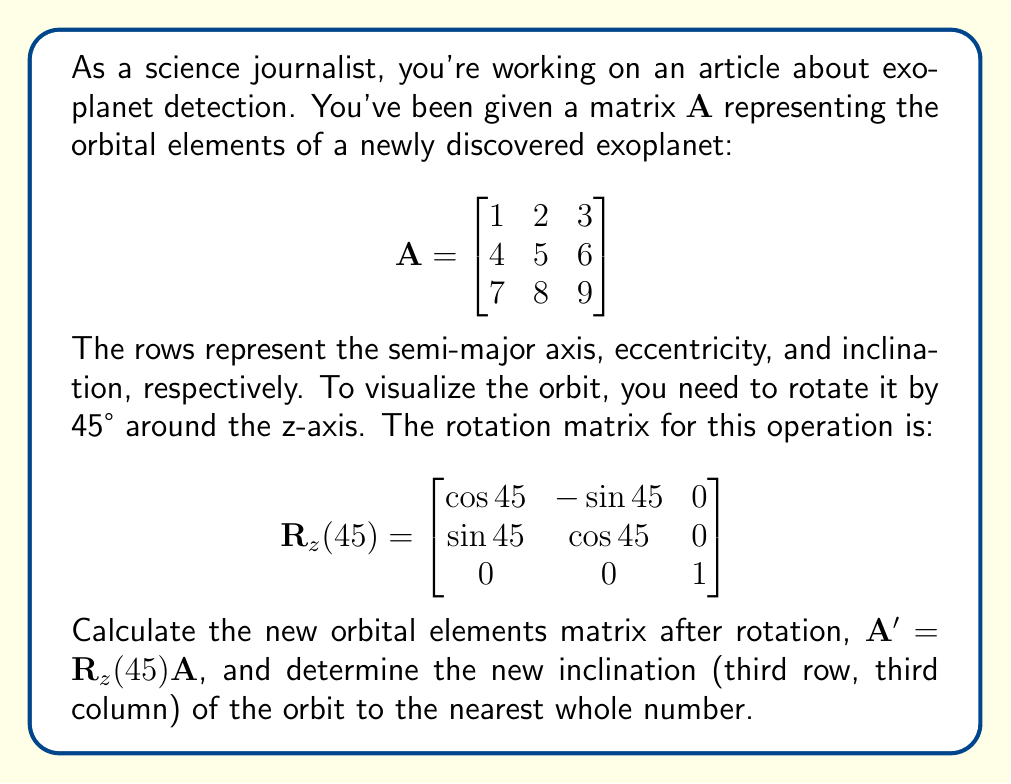Can you answer this question? Let's approach this step-by-step:

1) First, we need to calculate $\cos 45°$ and $\sin 45°$:
   $\cos 45° = \sin 45° = \frac{1}{\sqrt{2}} \approx 0.7071$

2) Now we can fill in the rotation matrix:

   $$\mathbf{R}_z(45°) = \begin{bmatrix}
   0.7071 & -0.7071 & 0 \\
   0.7071 & 0.7071 & 0 \\
   0 & 0 & 1
   \end{bmatrix}$$

3) To find $\mathbf{A}'$, we multiply $\mathbf{R}_z(45°)$ by $\mathbf{A}$:

   $$\mathbf{A}' = \mathbf{R}_z(45°) \mathbf{A} = \begin{bmatrix}
   0.7071 & -0.7071 & 0 \\
   0.7071 & 0.7071 & 0 \\
   0 & 0 & 1
   \end{bmatrix} \begin{bmatrix}
   1 & 2 & 3 \\
   4 & 5 & 6 \\
   7 & 8 & 9
   \end{bmatrix}$$

4) Performing the matrix multiplication:

   $$\mathbf{A}' = \begin{bmatrix}
   (0.7071 \times 1 + -0.7071 \times 4 + 0 \times 7) & (0.7071 \times 2 + -0.7071 \times 5 + 0 \times 8) & (0.7071 \times 3 + -0.7071 \times 6 + 0 \times 9) \\
   (0.7071 \times 1 + 0.7071 \times 4 + 0 \times 7) & (0.7071 \times 2 + 0.7071 \times 5 + 0 \times 8) & (0.7071 \times 3 + 0.7071 \times 6 + 0 \times 9) \\
   (0 \times 1 + 0 \times 4 + 1 \times 7) & (0 \times 2 + 0 \times 5 + 1 \times 8) & (0 \times 3 + 0 \times 6 + 1 \times 9)
   \end{bmatrix}$$

5) Simplifying:

   $$\mathbf{A}' = \begin{bmatrix}
   -2.1213 & -2.1213 & -2.1213 \\
   3.5355 & 4.9497 & 6.3640 \\
   7 & 8 & 9
   \end{bmatrix}$$

6) The new inclination is the element in the third row, third column of $\mathbf{A}'$, which is 9.

7) Rounding to the nearest whole number: 9
Answer: 9 